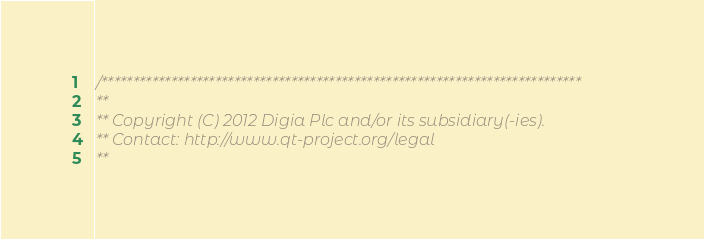Convert code to text. <code><loc_0><loc_0><loc_500><loc_500><_ObjectiveC_>/****************************************************************************
**
** Copyright (C) 2012 Digia Plc and/or its subsidiary(-ies).
** Contact: http://www.qt-project.org/legal
**</code> 